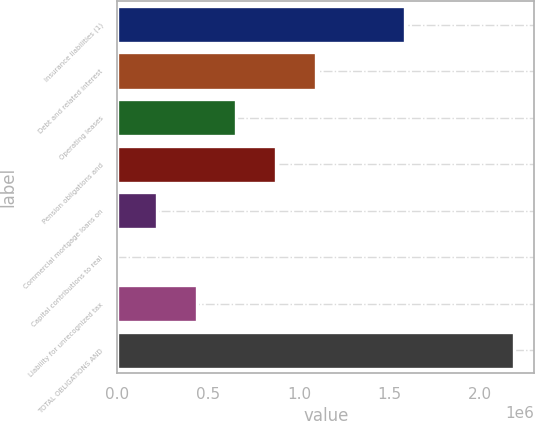Convert chart to OTSL. <chart><loc_0><loc_0><loc_500><loc_500><bar_chart><fcel>Insurance liabilities (1)<fcel>Debt and related interest<fcel>Operating leases<fcel>Pension obligations and<fcel>Commercial mortgage loans on<fcel>Capital contributions to real<fcel>Liability for unrecognized tax<fcel>TOTAL OBLIGATIONS AND<nl><fcel>1.58537e+06<fcel>1.09329e+06<fcel>655972<fcel>874629<fcel>218658<fcel>0.5<fcel>437315<fcel>2.18657e+06<nl></chart> 